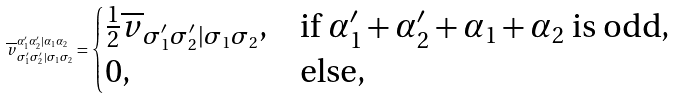Convert formula to latex. <formula><loc_0><loc_0><loc_500><loc_500>\overline { v } ^ { \alpha ^ { \prime } _ { 1 } \alpha ^ { \prime } _ { 2 } | \alpha _ { 1 } \alpha _ { 2 } } _ { \sigma ^ { \prime } _ { 1 } \sigma ^ { \prime } _ { 2 } | \sigma _ { 1 } \sigma _ { 2 } } = \begin{cases} \frac { 1 } { 2 } \overline { v } _ { \sigma ^ { \prime } _ { 1 } \sigma ^ { \prime } _ { 2 } | \sigma _ { 1 } \sigma _ { 2 } } , & \text {if $\alpha^{\prime}_{1} + \alpha^{\prime}_{2} + \alpha_{1} + \alpha_{2}$ is odd} , \\ 0 , & \text {else} , \end{cases}</formula> 